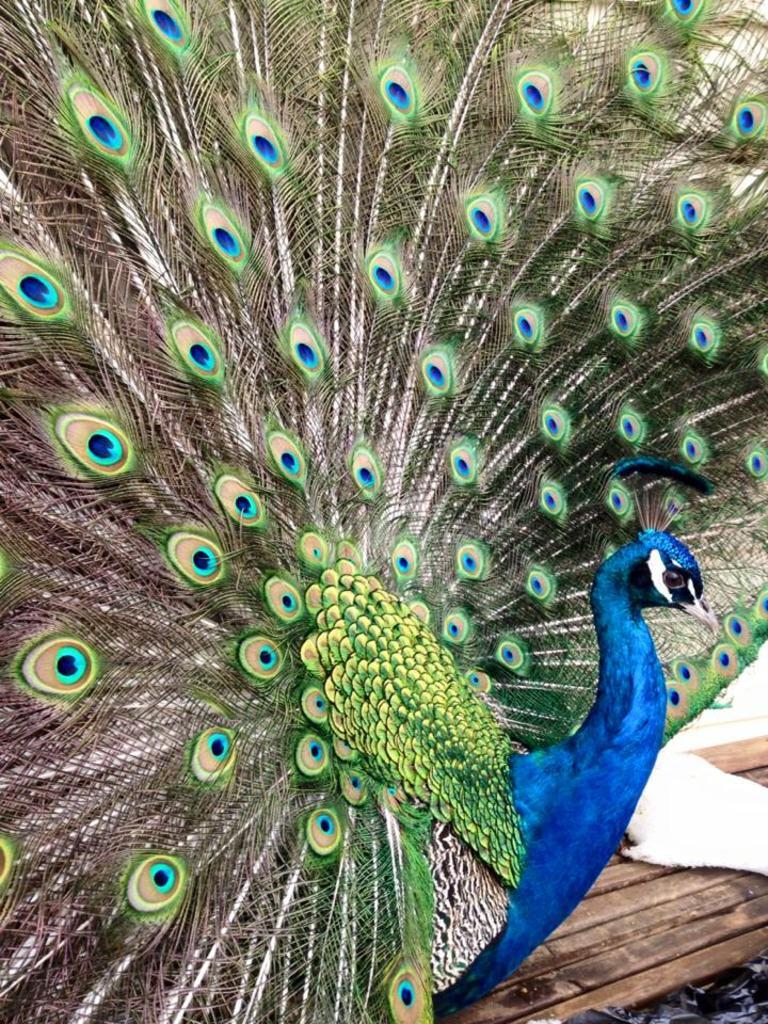What type of animal is in the image? There is a peacock in the image. Where is the peacock located in the image? The peacock is standing on a table. What does the farmer feel towards the peacock in the image? There is no farmer present in the image, so it is not possible to determine their feelings towards the peacock. 